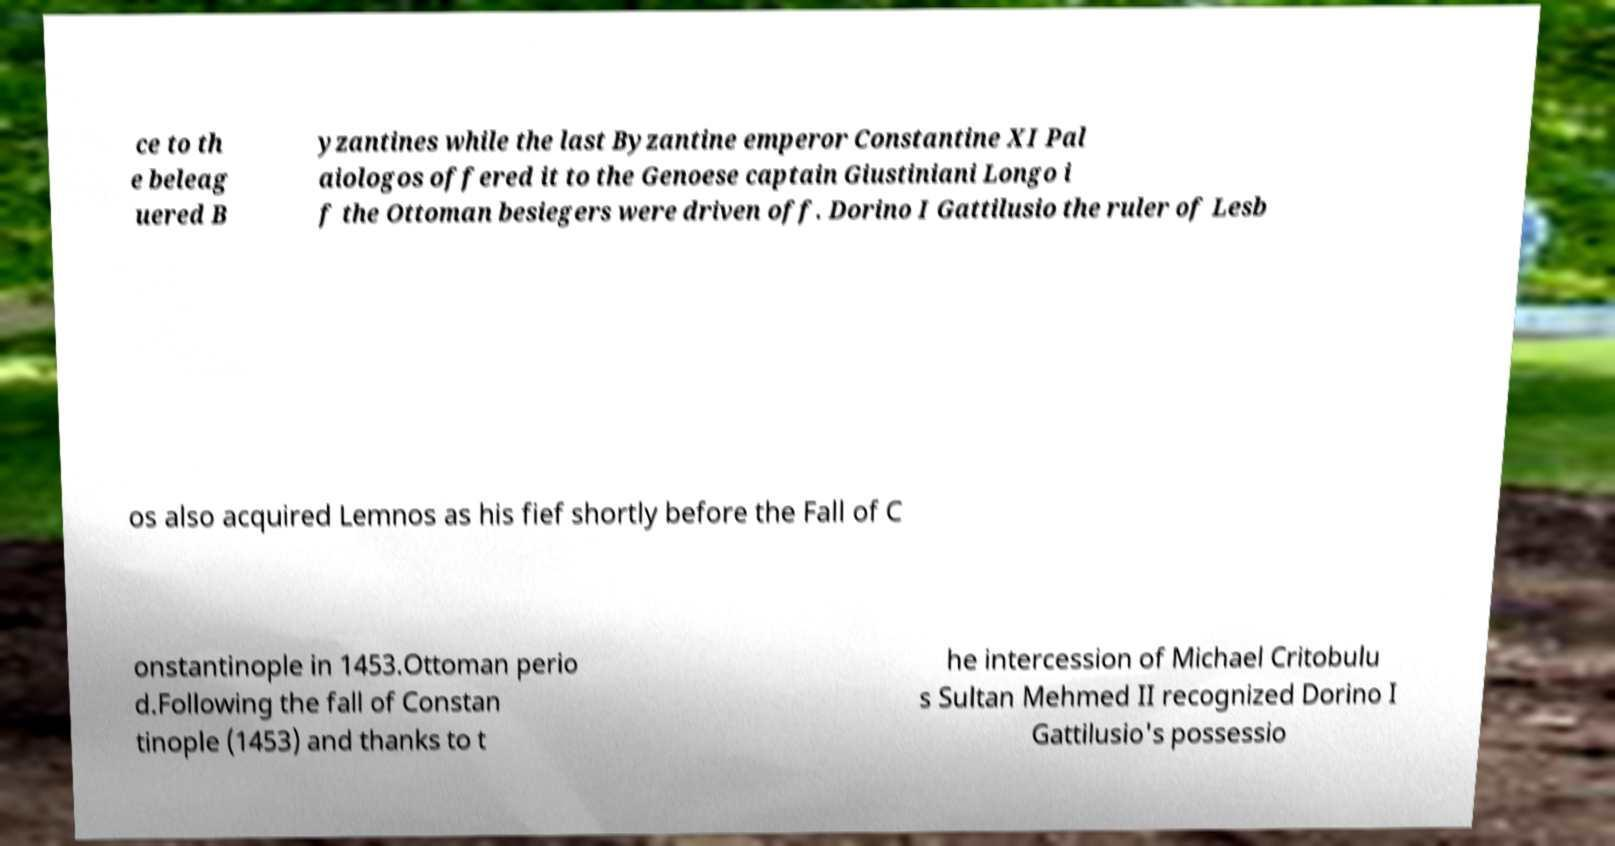Could you assist in decoding the text presented in this image and type it out clearly? ce to th e beleag uered B yzantines while the last Byzantine emperor Constantine XI Pal aiologos offered it to the Genoese captain Giustiniani Longo i f the Ottoman besiegers were driven off. Dorino I Gattilusio the ruler of Lesb os also acquired Lemnos as his fief shortly before the Fall of C onstantinople in 1453.Ottoman perio d.Following the fall of Constan tinople (1453) and thanks to t he intercession of Michael Critobulu s Sultan Mehmed II recognized Dorino I Gattilusio's possessio 